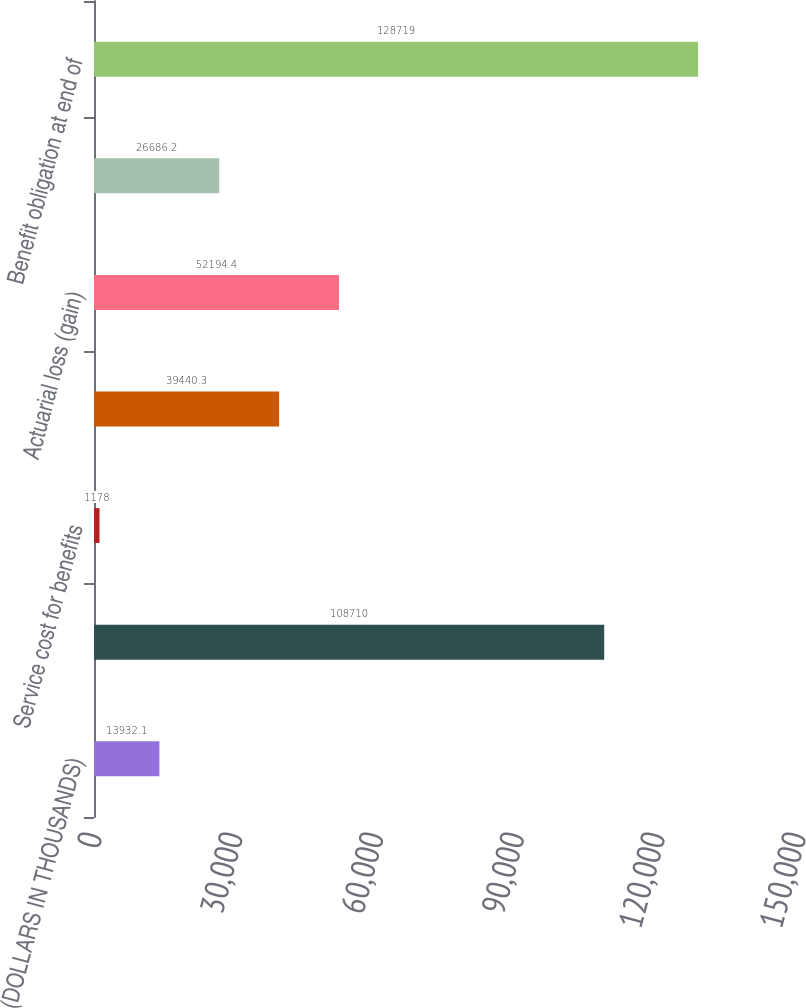<chart> <loc_0><loc_0><loc_500><loc_500><bar_chart><fcel>(DOLLARS IN THOUSANDS)<fcel>Benefit obligation at<fcel>Service cost for benefits<fcel>Interest cost on projected<fcel>Actuarial loss (gain)<fcel>Benefits paid<fcel>Benefit obligation at end of<nl><fcel>13932.1<fcel>108710<fcel>1178<fcel>39440.3<fcel>52194.4<fcel>26686.2<fcel>128719<nl></chart> 